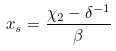Convert formula to latex. <formula><loc_0><loc_0><loc_500><loc_500>x _ { s } = \frac { \chi _ { 2 } - \delta ^ { - 1 } } { \beta }</formula> 